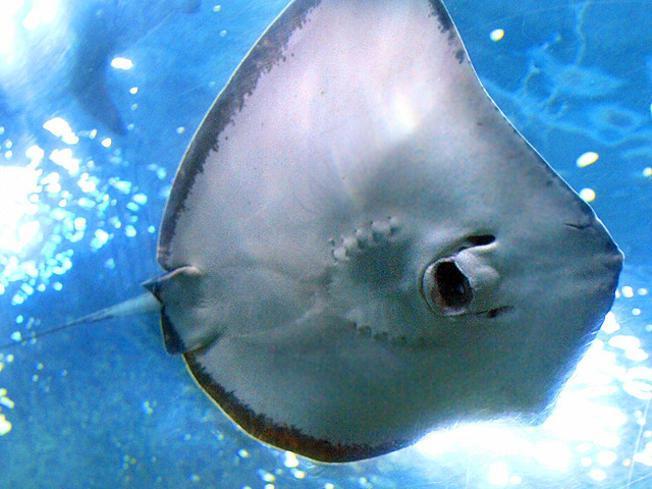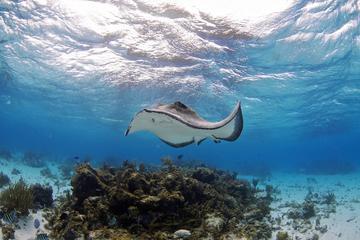The first image is the image on the left, the second image is the image on the right. Considering the images on both sides, is "There are at least 8 stingrays near the ocean floor." valid? Answer yes or no. No. The first image is the image on the left, the second image is the image on the right. Evaluate the accuracy of this statement regarding the images: "There are at most three stingrays.". Is it true? Answer yes or no. Yes. 